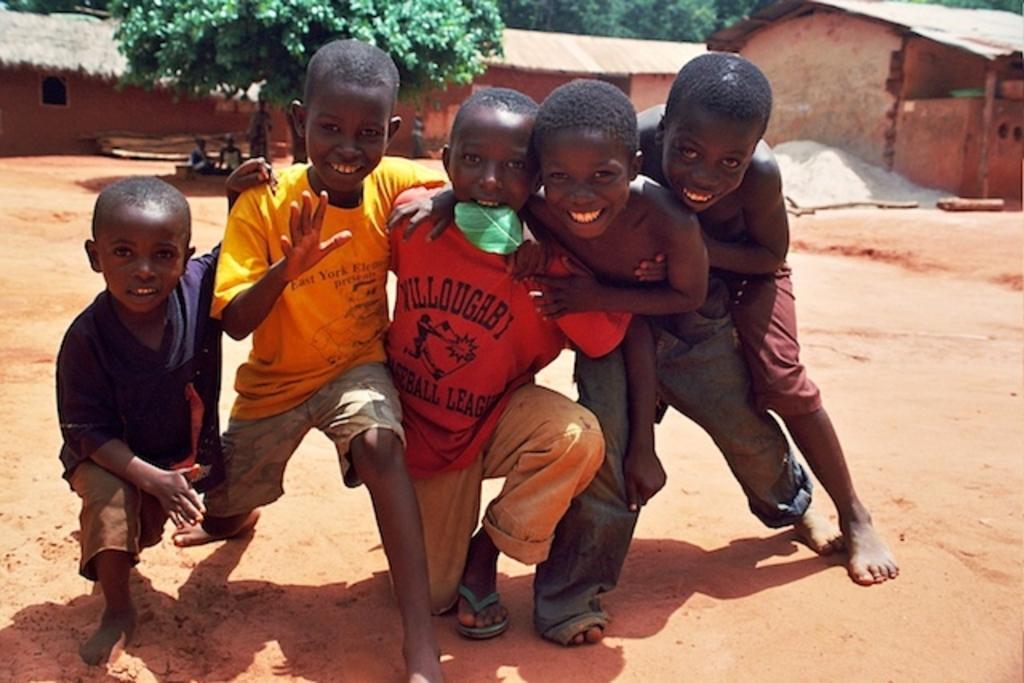Could you give a brief overview of what you see in this image? In this image, we can see a group of kids are on the ground. They are watching. Few are smiling. Here we can see a leaf in the mouth of a kid. Background we can see few houses, trees, walls, few objects and people. 